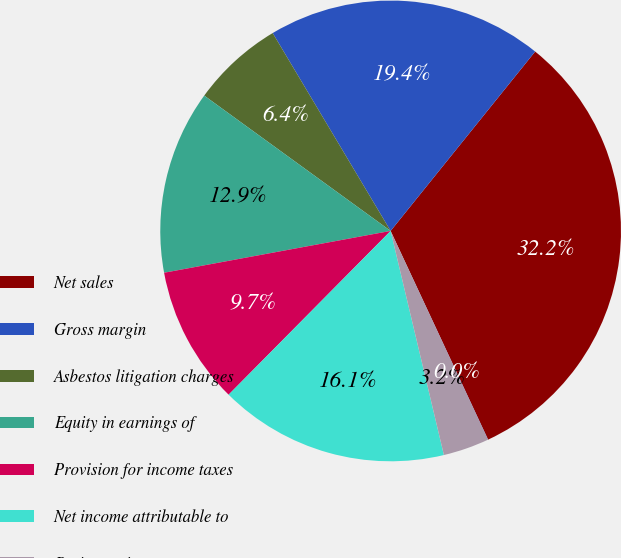Convert chart to OTSL. <chart><loc_0><loc_0><loc_500><loc_500><pie_chart><fcel>Net sales<fcel>Gross margin<fcel>Asbestos litigation charges<fcel>Equity in earnings of<fcel>Provision for income taxes<fcel>Net income attributable to<fcel>Basic earnings per common<fcel>Diluted earnings per common<nl><fcel>32.25%<fcel>19.35%<fcel>6.45%<fcel>12.9%<fcel>9.68%<fcel>16.13%<fcel>3.23%<fcel>0.01%<nl></chart> 